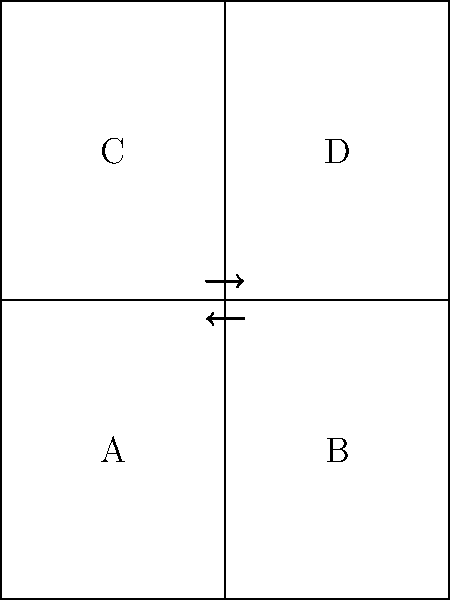As a communications major familiar with traditional print media, you understand the importance of properly folding a newspaper for easy reading and storage. Given the diagram of an unfolded newspaper with sections A, B, C, and D, what is the correct sequence of folds to create a compact, properly folded newspaper? To fold a traditional newspaper correctly, follow these steps:

1. Start with the newspaper fully unfolded, as shown in the diagram.
2. First fold: Bring the right half (sections B and D) over the left half (sections A and C). This aligns the vertical dashed line.
3. Second fold: Bring the bottom half (now containing C and D) up to meet the top half (A and B). This aligns the horizontal dashed line.

The folding process follows these principles:
- It maintains the traditional layout of newspaper sections.
- It creates a compact form that's easy to handle and store.
- It allows for quick access to different sections when unfolding.

This method of folding has been the standard in the newspaper industry for decades, aligning with the traditional policies and practices in print media communication.
Answer: Right half over left, then bottom half up 